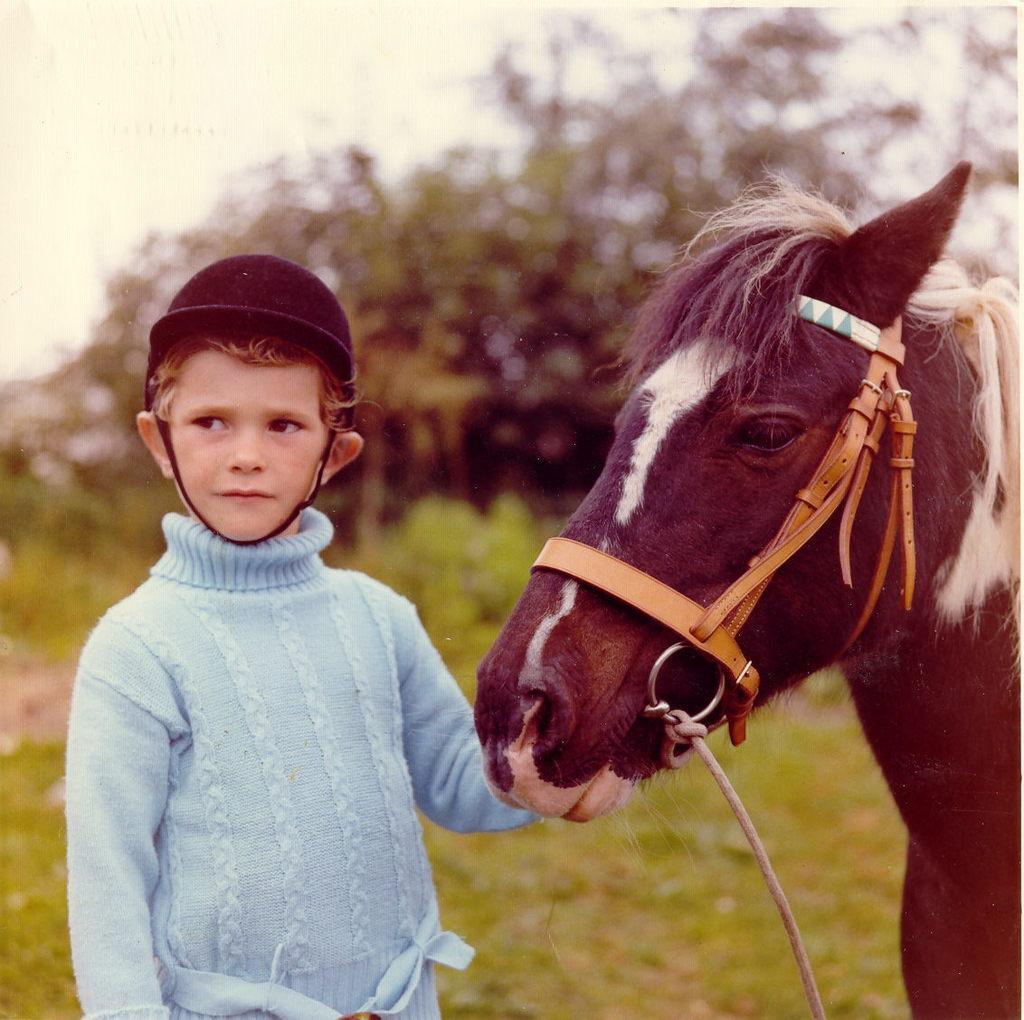Please provide a concise description of this image. There is a horse on the right side and the boy is standing in left side keeping his hand on the horse.
In the background there are some tree. 